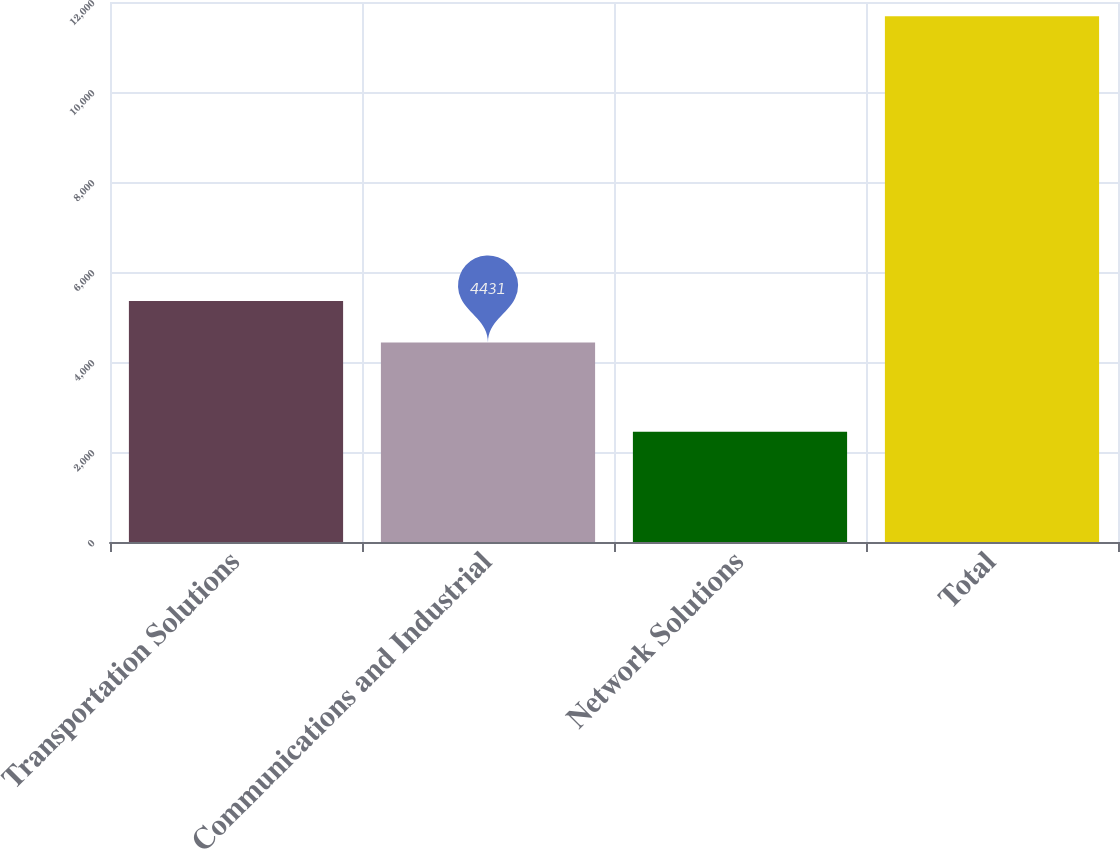Convert chart to OTSL. <chart><loc_0><loc_0><loc_500><loc_500><bar_chart><fcel>Transportation Solutions<fcel>Communications and Industrial<fcel>Network Solutions<fcel>Total<nl><fcel>5354<fcel>4431<fcel>2451<fcel>11681<nl></chart> 